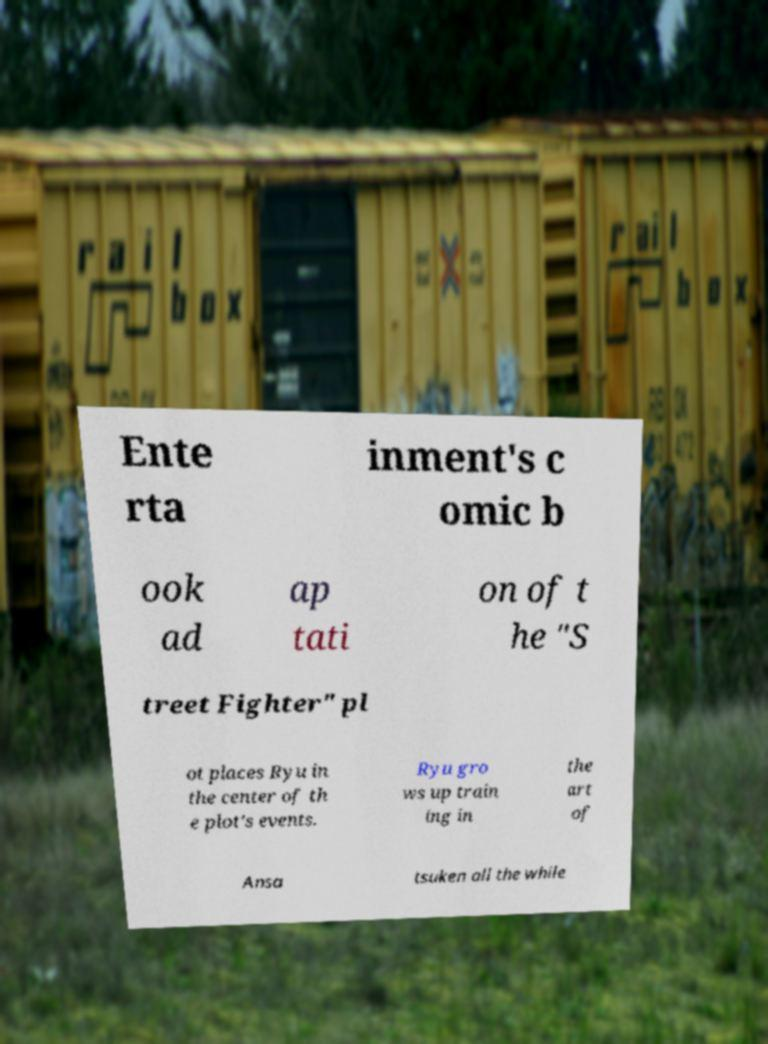There's text embedded in this image that I need extracted. Can you transcribe it verbatim? Ente rta inment's c omic b ook ad ap tati on of t he "S treet Fighter" pl ot places Ryu in the center of th e plot's events. Ryu gro ws up train ing in the art of Ansa tsuken all the while 